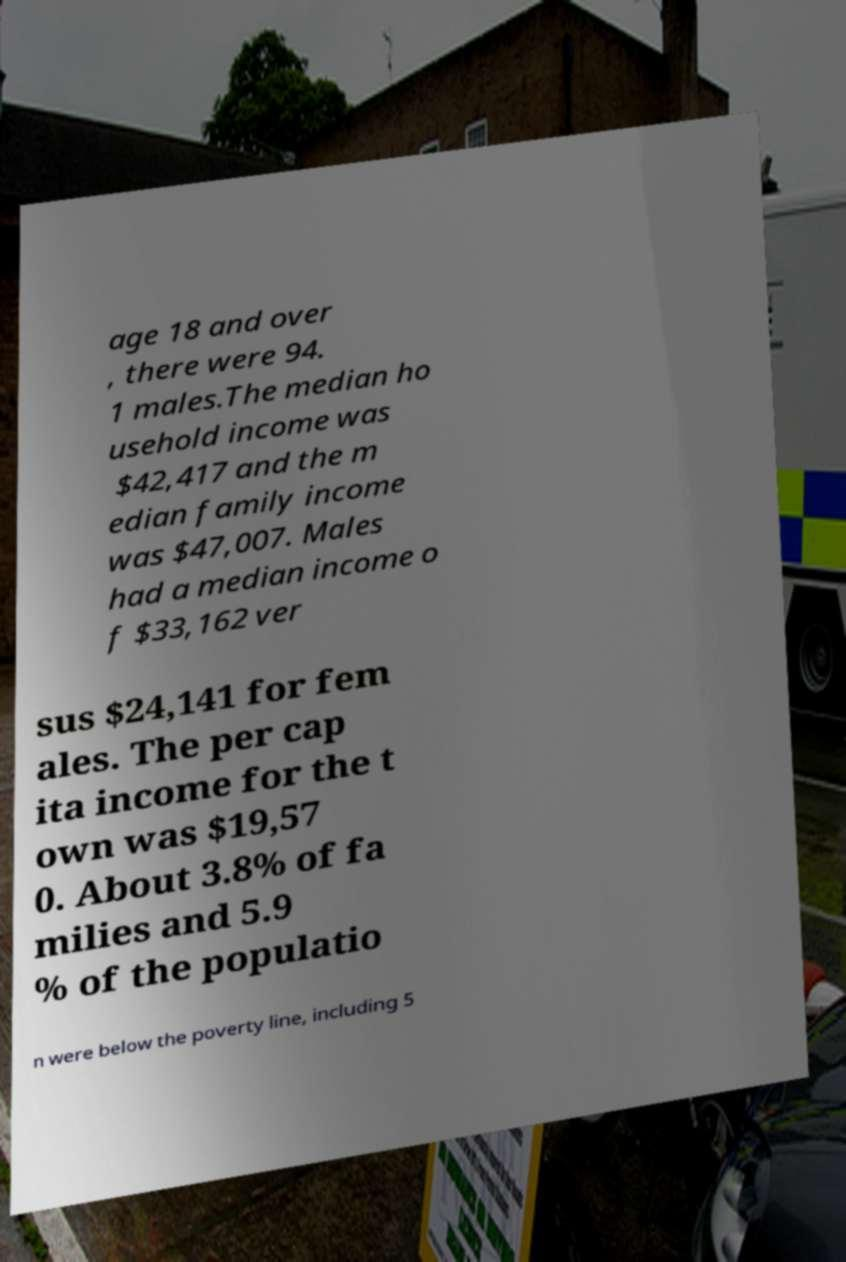There's text embedded in this image that I need extracted. Can you transcribe it verbatim? age 18 and over , there were 94. 1 males.The median ho usehold income was $42,417 and the m edian family income was $47,007. Males had a median income o f $33,162 ver sus $24,141 for fem ales. The per cap ita income for the t own was $19,57 0. About 3.8% of fa milies and 5.9 % of the populatio n were below the poverty line, including 5 